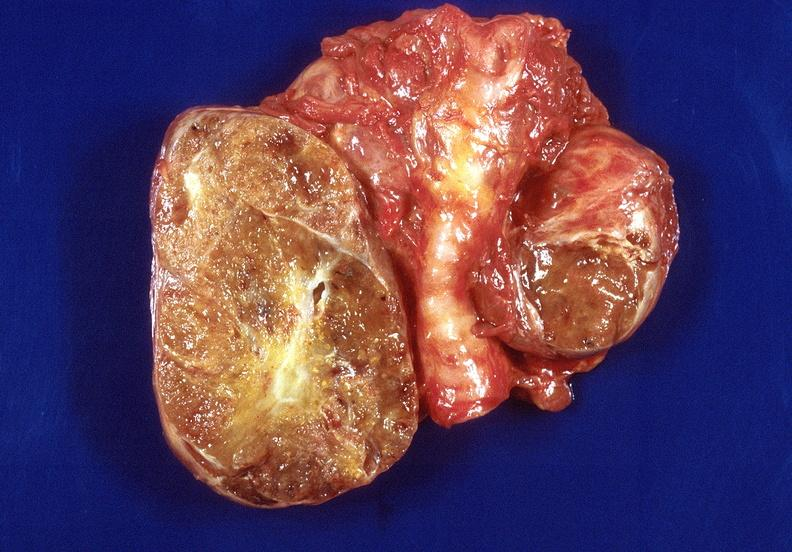what does this image show?
Answer the question using a single word or phrase. Thyroid 